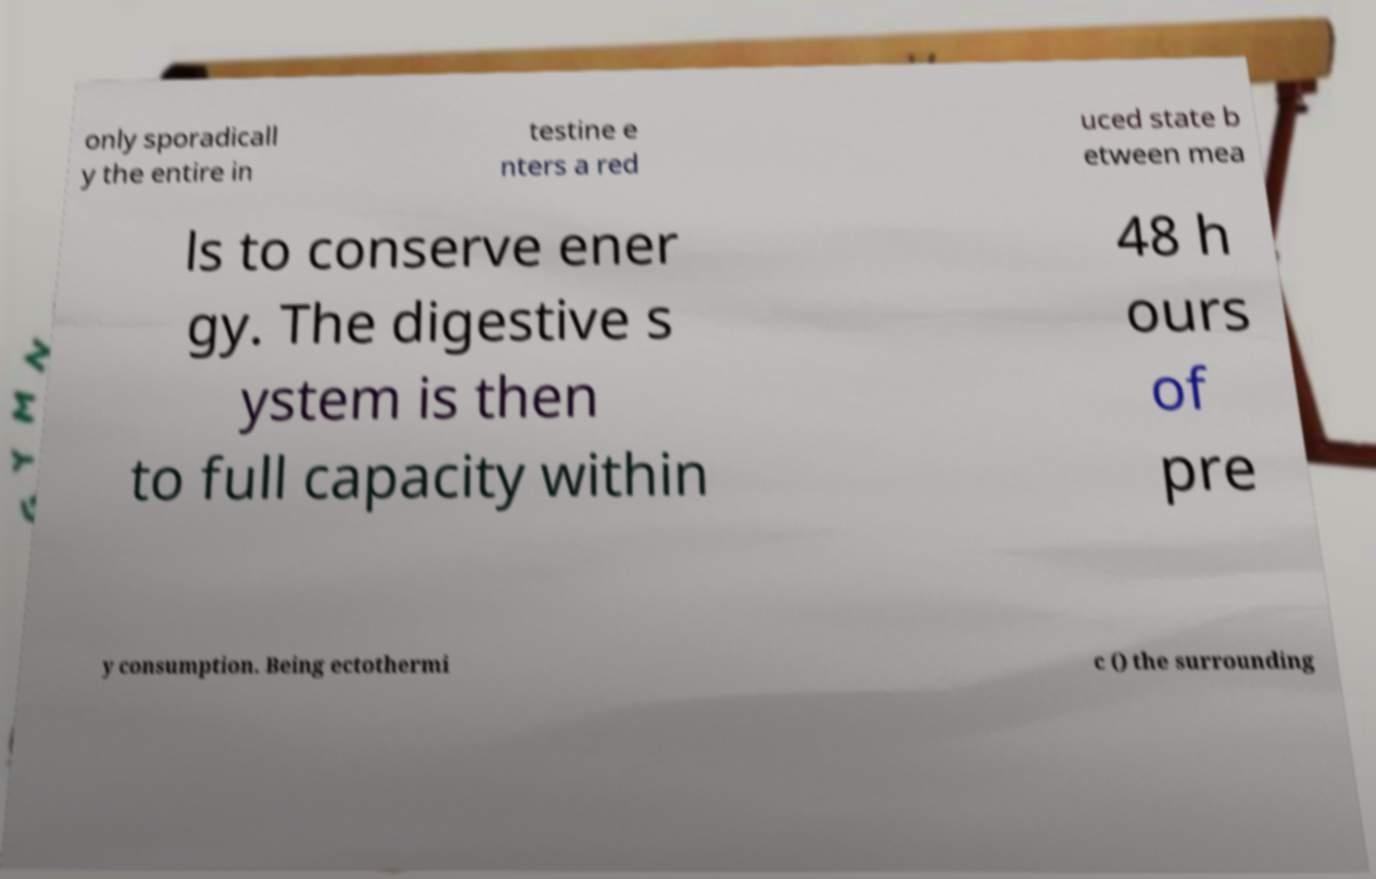Please identify and transcribe the text found in this image. only sporadicall y the entire in testine e nters a red uced state b etween mea ls to conserve ener gy. The digestive s ystem is then to full capacity within 48 h ours of pre y consumption. Being ectothermi c () the surrounding 